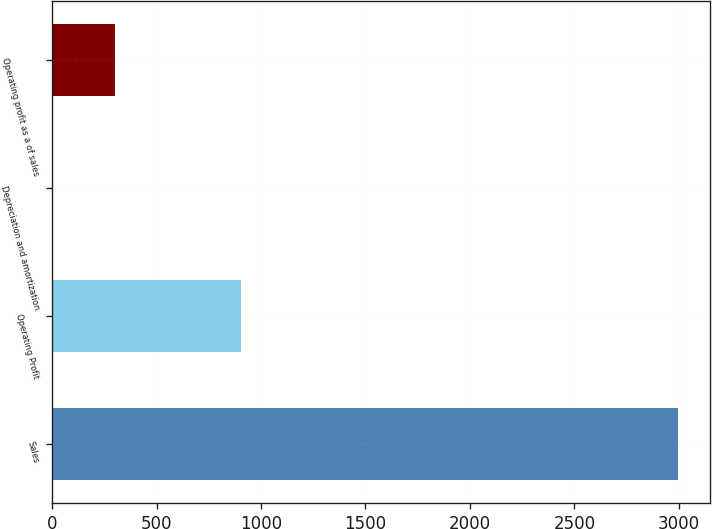<chart> <loc_0><loc_0><loc_500><loc_500><bar_chart><fcel>Sales<fcel>Operating Profit<fcel>Depreciation and amortization<fcel>Operating profit as a of sales<nl><fcel>2998<fcel>902.2<fcel>4<fcel>303.4<nl></chart> 